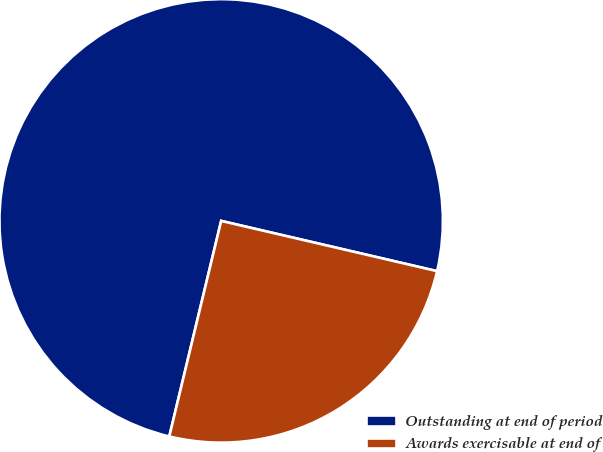<chart> <loc_0><loc_0><loc_500><loc_500><pie_chart><fcel>Outstanding at end of period<fcel>Awards exercisable at end of<nl><fcel>74.88%<fcel>25.12%<nl></chart> 